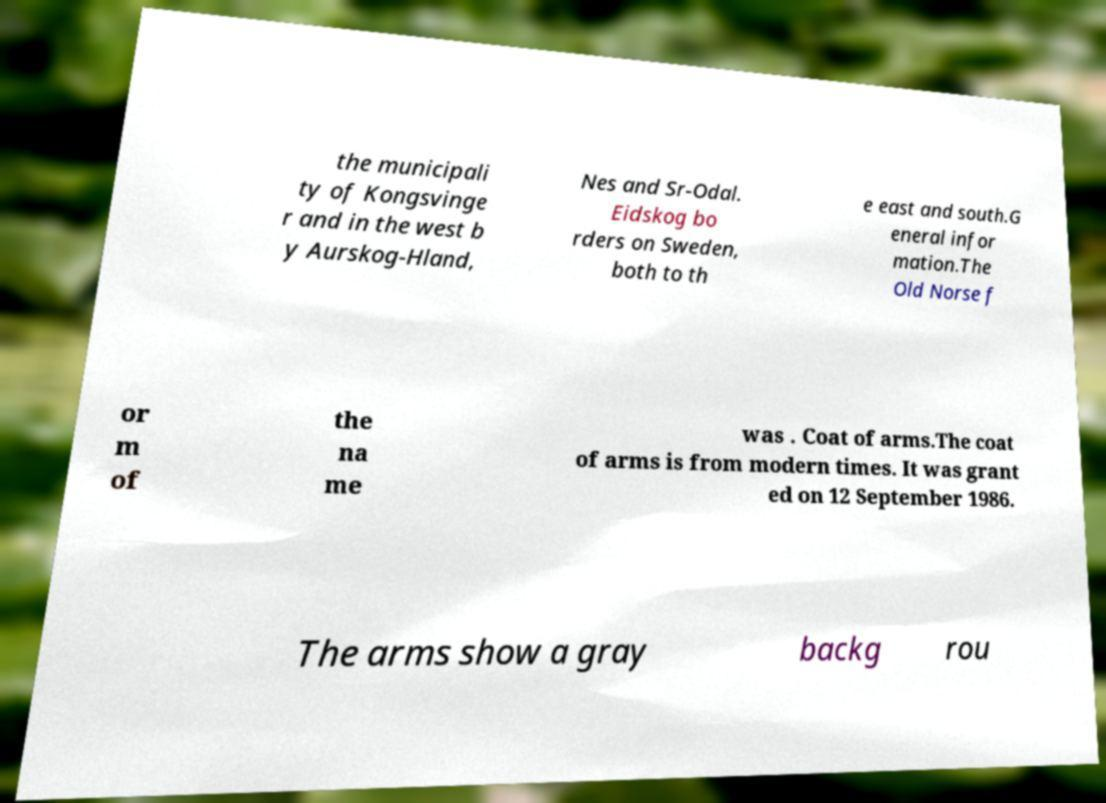What messages or text are displayed in this image? I need them in a readable, typed format. the municipali ty of Kongsvinge r and in the west b y Aurskog-Hland, Nes and Sr-Odal. Eidskog bo rders on Sweden, both to th e east and south.G eneral infor mation.The Old Norse f or m of the na me was . Coat of arms.The coat of arms is from modern times. It was grant ed on 12 September 1986. The arms show a gray backg rou 